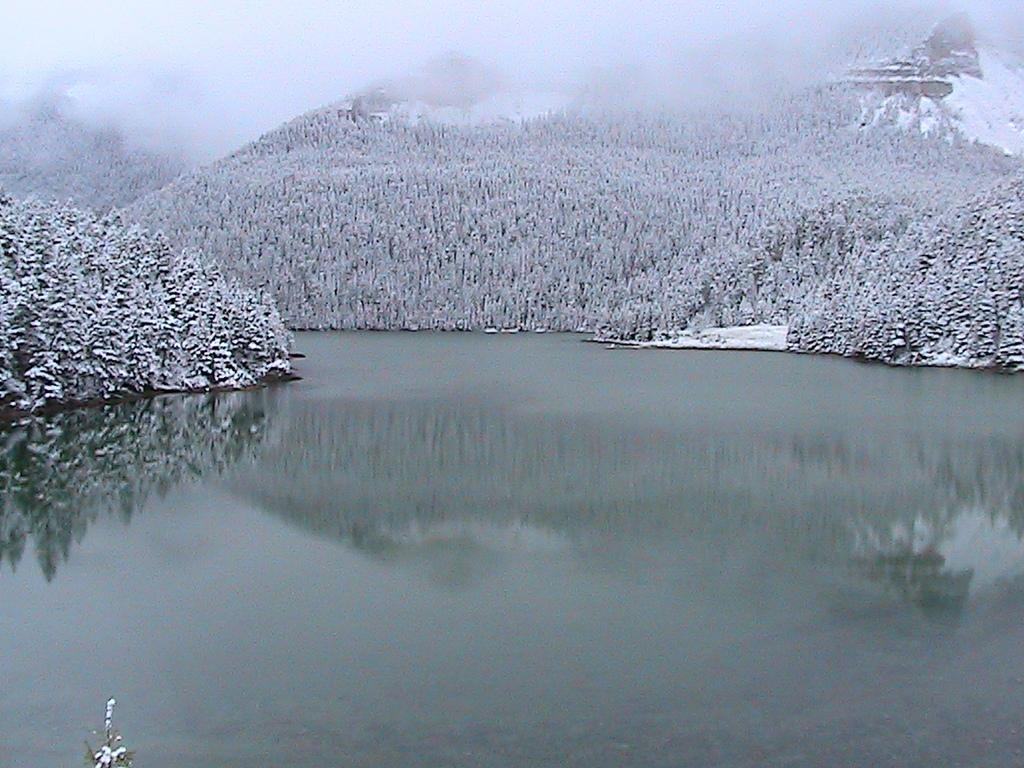What is the primary element visible in the image? There is water in the image. What geographical features can be seen in the image? There are hills in the image. What is growing on the hills? The hills have trees on them. What is the condition of the trees in the image? The trees are covered with snow. What type of pump can be seen operating near the trees in the image? There is no pump present in the image; it features water, hills, trees, and snow. 